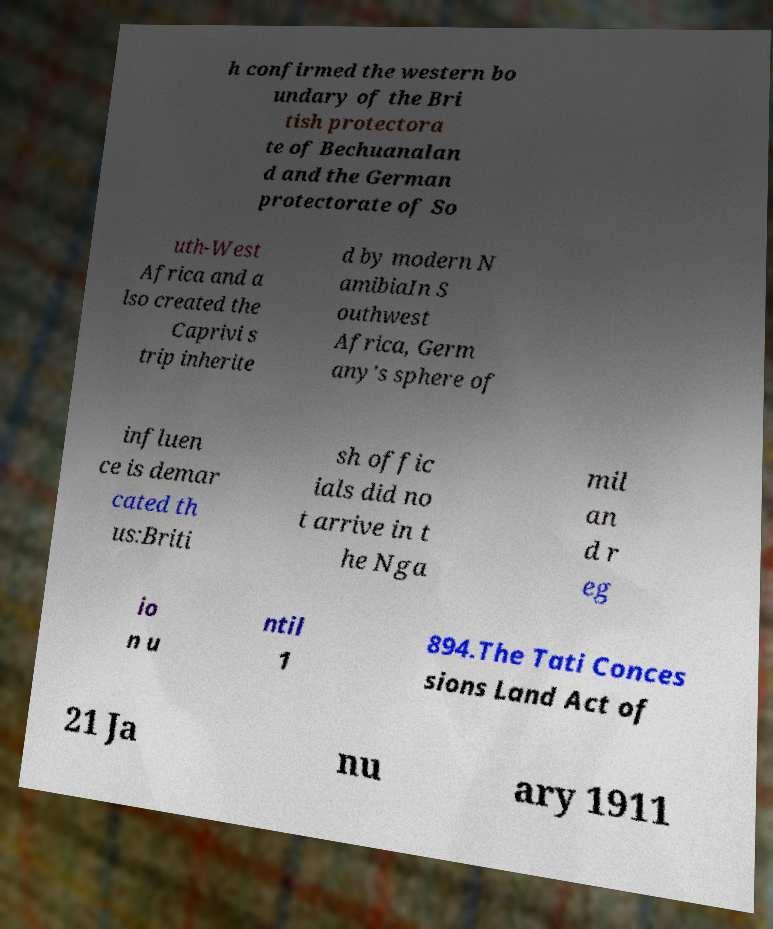Could you assist in decoding the text presented in this image and type it out clearly? h confirmed the western bo undary of the Bri tish protectora te of Bechuanalan d and the German protectorate of So uth-West Africa and a lso created the Caprivi s trip inherite d by modern N amibiaIn S outhwest Africa, Germ any's sphere of influen ce is demar cated th us:Briti sh offic ials did no t arrive in t he Nga mil an d r eg io n u ntil 1 894.The Tati Conces sions Land Act of 21 Ja nu ary 1911 